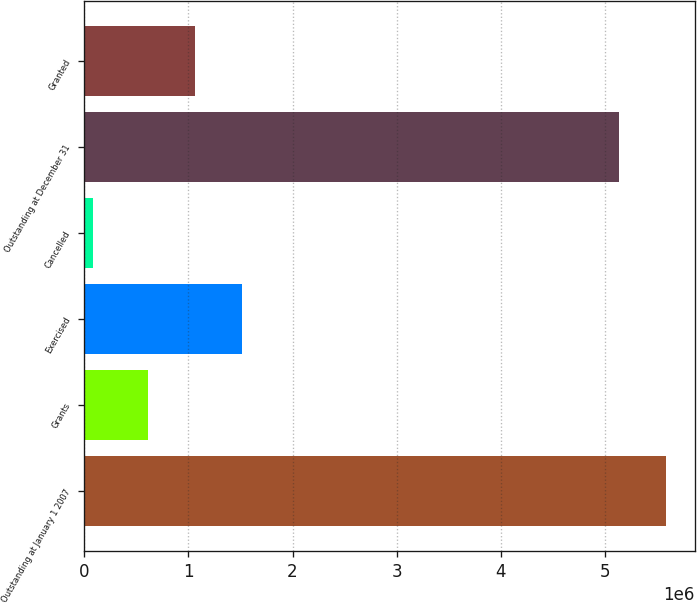Convert chart. <chart><loc_0><loc_0><loc_500><loc_500><bar_chart><fcel>Outstanding at January 1 2007<fcel>Grants<fcel>Exercised<fcel>Cancelled<fcel>Outstanding at December 31<fcel>Granted<nl><fcel>5.57854e+06<fcel>616450<fcel>1.51459e+06<fcel>88100<fcel>5.12946e+06<fcel>1.06552e+06<nl></chart> 